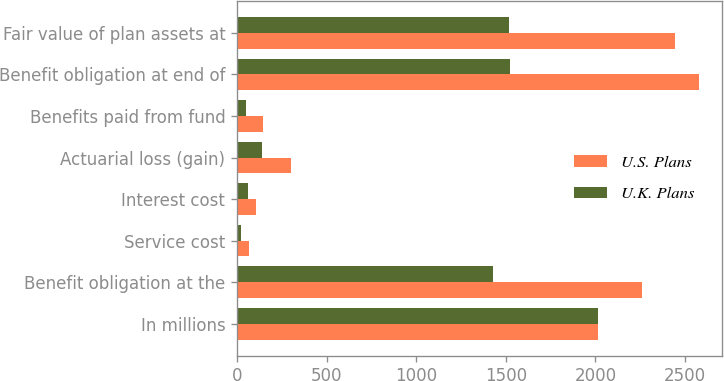Convert chart to OTSL. <chart><loc_0><loc_0><loc_500><loc_500><stacked_bar_chart><ecel><fcel>In millions<fcel>Benefit obligation at the<fcel>Service cost<fcel>Interest cost<fcel>Actuarial loss (gain)<fcel>Benefits paid from fund<fcel>Benefit obligation at end of<fcel>Fair value of plan assets at<nl><fcel>U.S. Plans<fcel>2014<fcel>2261<fcel>66<fcel>105<fcel>301<fcel>143<fcel>2579<fcel>2445<nl><fcel>U.K. Plans<fcel>2014<fcel>1429<fcel>24<fcel>63<fcel>139<fcel>48<fcel>1522<fcel>1516<nl></chart> 